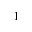Convert formula to latex. <formula><loc_0><loc_0><loc_500><loc_500>^ { 1 }</formula> 